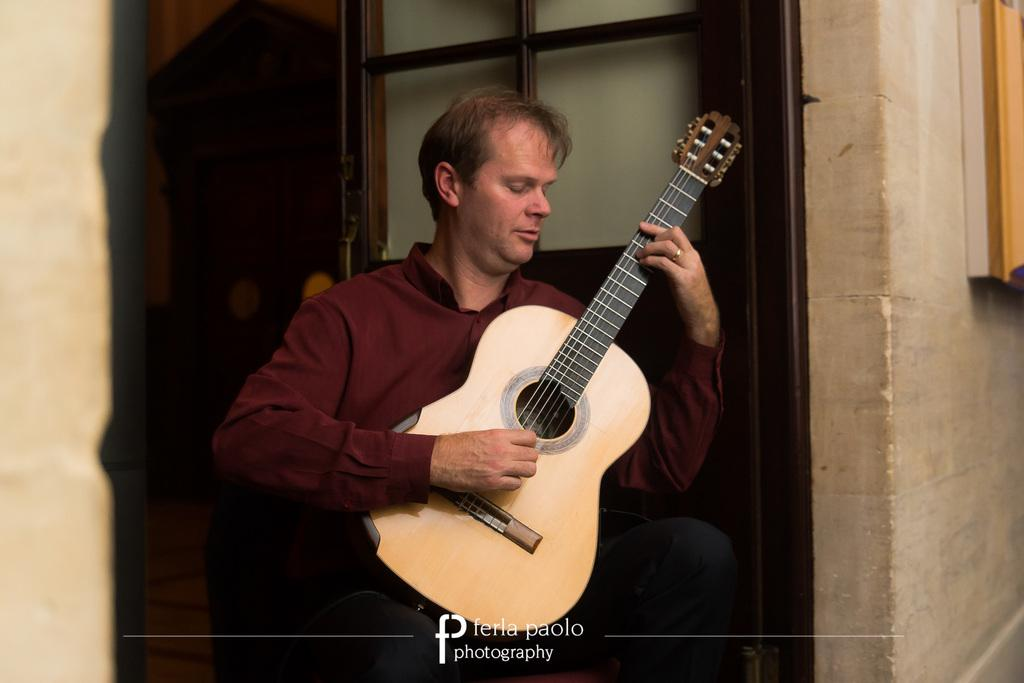What is the man in the image doing? The man is playing a guitar in the image. Can you describe the man's location in the image? The man is standing in the middle of the image. What is located behind the man? There is a door behind the man. What is behind the door in the image? There is a wall behind the door. What type of beetle can be seen attacking the man in the image? There is no beetle present in the image, and the man is not being attacked. 